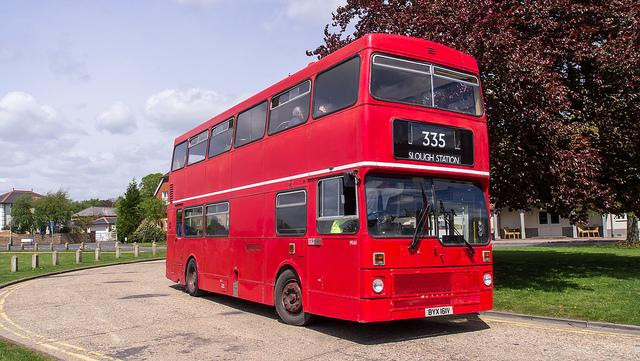One can board a train in which region after they disembark from this bus? slough station 